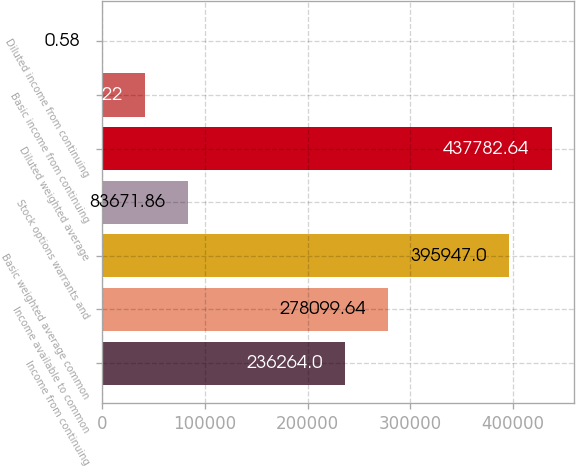<chart> <loc_0><loc_0><loc_500><loc_500><bar_chart><fcel>Income from continuing<fcel>Income available to common<fcel>Basic weighted average common<fcel>Stock options warrants and<fcel>Diluted weighted average<fcel>Basic income from continuing<fcel>Diluted income from continuing<nl><fcel>236264<fcel>278100<fcel>395947<fcel>83671.9<fcel>437783<fcel>41836.2<fcel>0.58<nl></chart> 